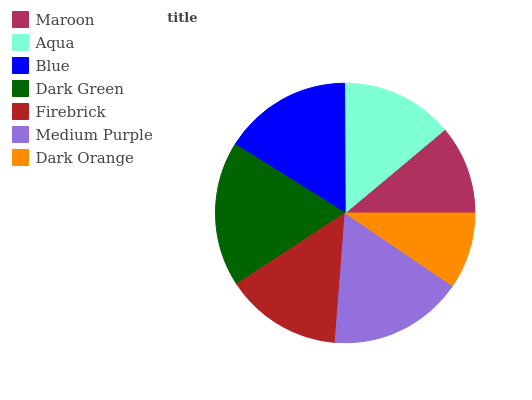Is Dark Orange the minimum?
Answer yes or no. Yes. Is Dark Green the maximum?
Answer yes or no. Yes. Is Aqua the minimum?
Answer yes or no. No. Is Aqua the maximum?
Answer yes or no. No. Is Aqua greater than Maroon?
Answer yes or no. Yes. Is Maroon less than Aqua?
Answer yes or no. Yes. Is Maroon greater than Aqua?
Answer yes or no. No. Is Aqua less than Maroon?
Answer yes or no. No. Is Firebrick the high median?
Answer yes or no. Yes. Is Firebrick the low median?
Answer yes or no. Yes. Is Blue the high median?
Answer yes or no. No. Is Blue the low median?
Answer yes or no. No. 